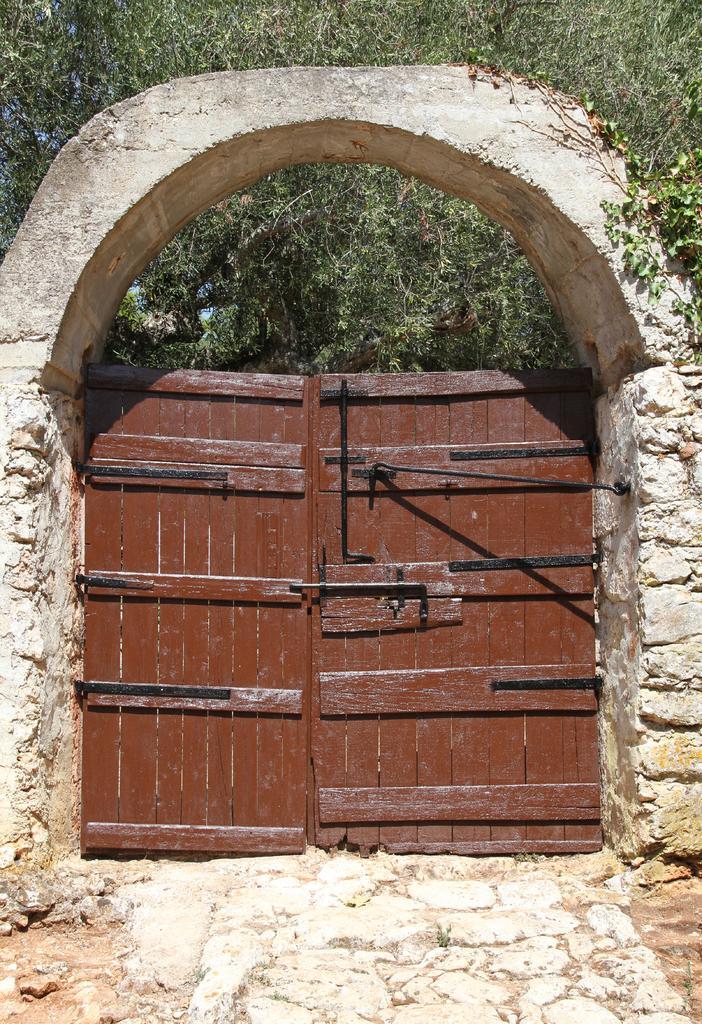Please provide a concise description of this image. This picture contains a door in brown color. Beside that, we see a wall in white color. There are trees in the background. 